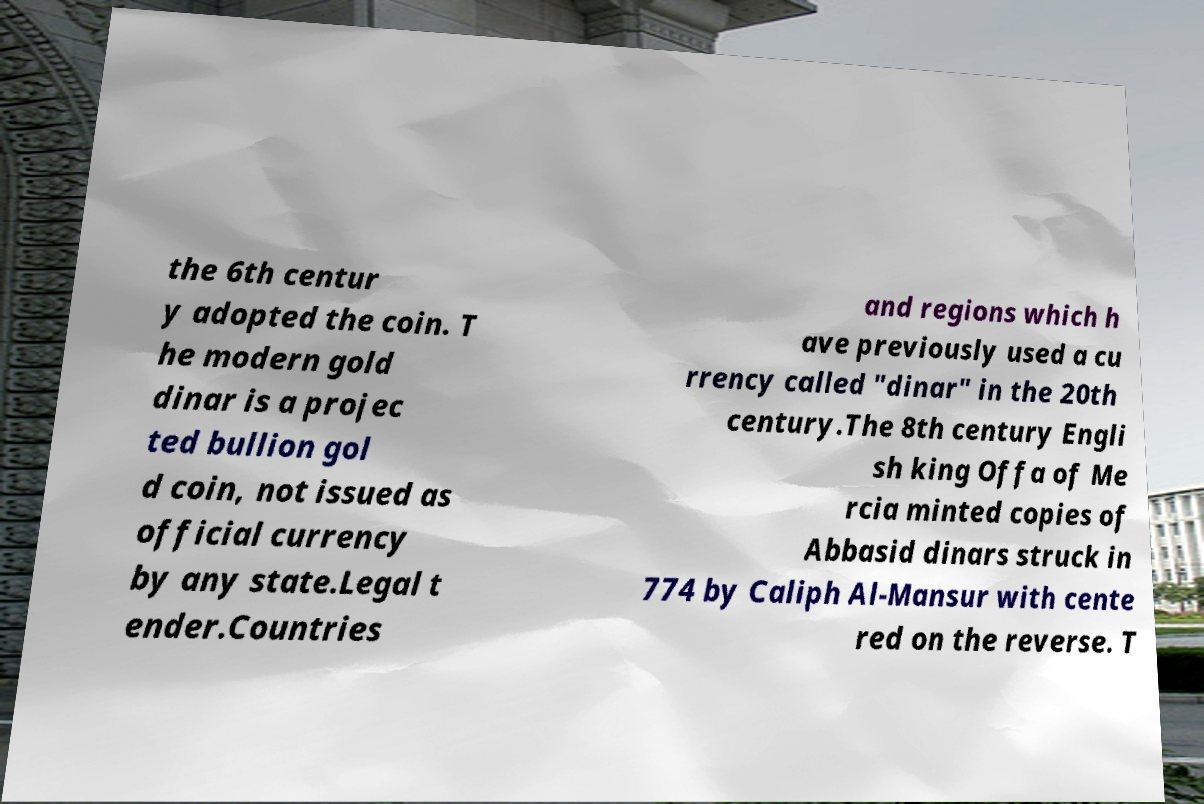Could you assist in decoding the text presented in this image and type it out clearly? the 6th centur y adopted the coin. T he modern gold dinar is a projec ted bullion gol d coin, not issued as official currency by any state.Legal t ender.Countries and regions which h ave previously used a cu rrency called "dinar" in the 20th century.The 8th century Engli sh king Offa of Me rcia minted copies of Abbasid dinars struck in 774 by Caliph Al-Mansur with cente red on the reverse. T 